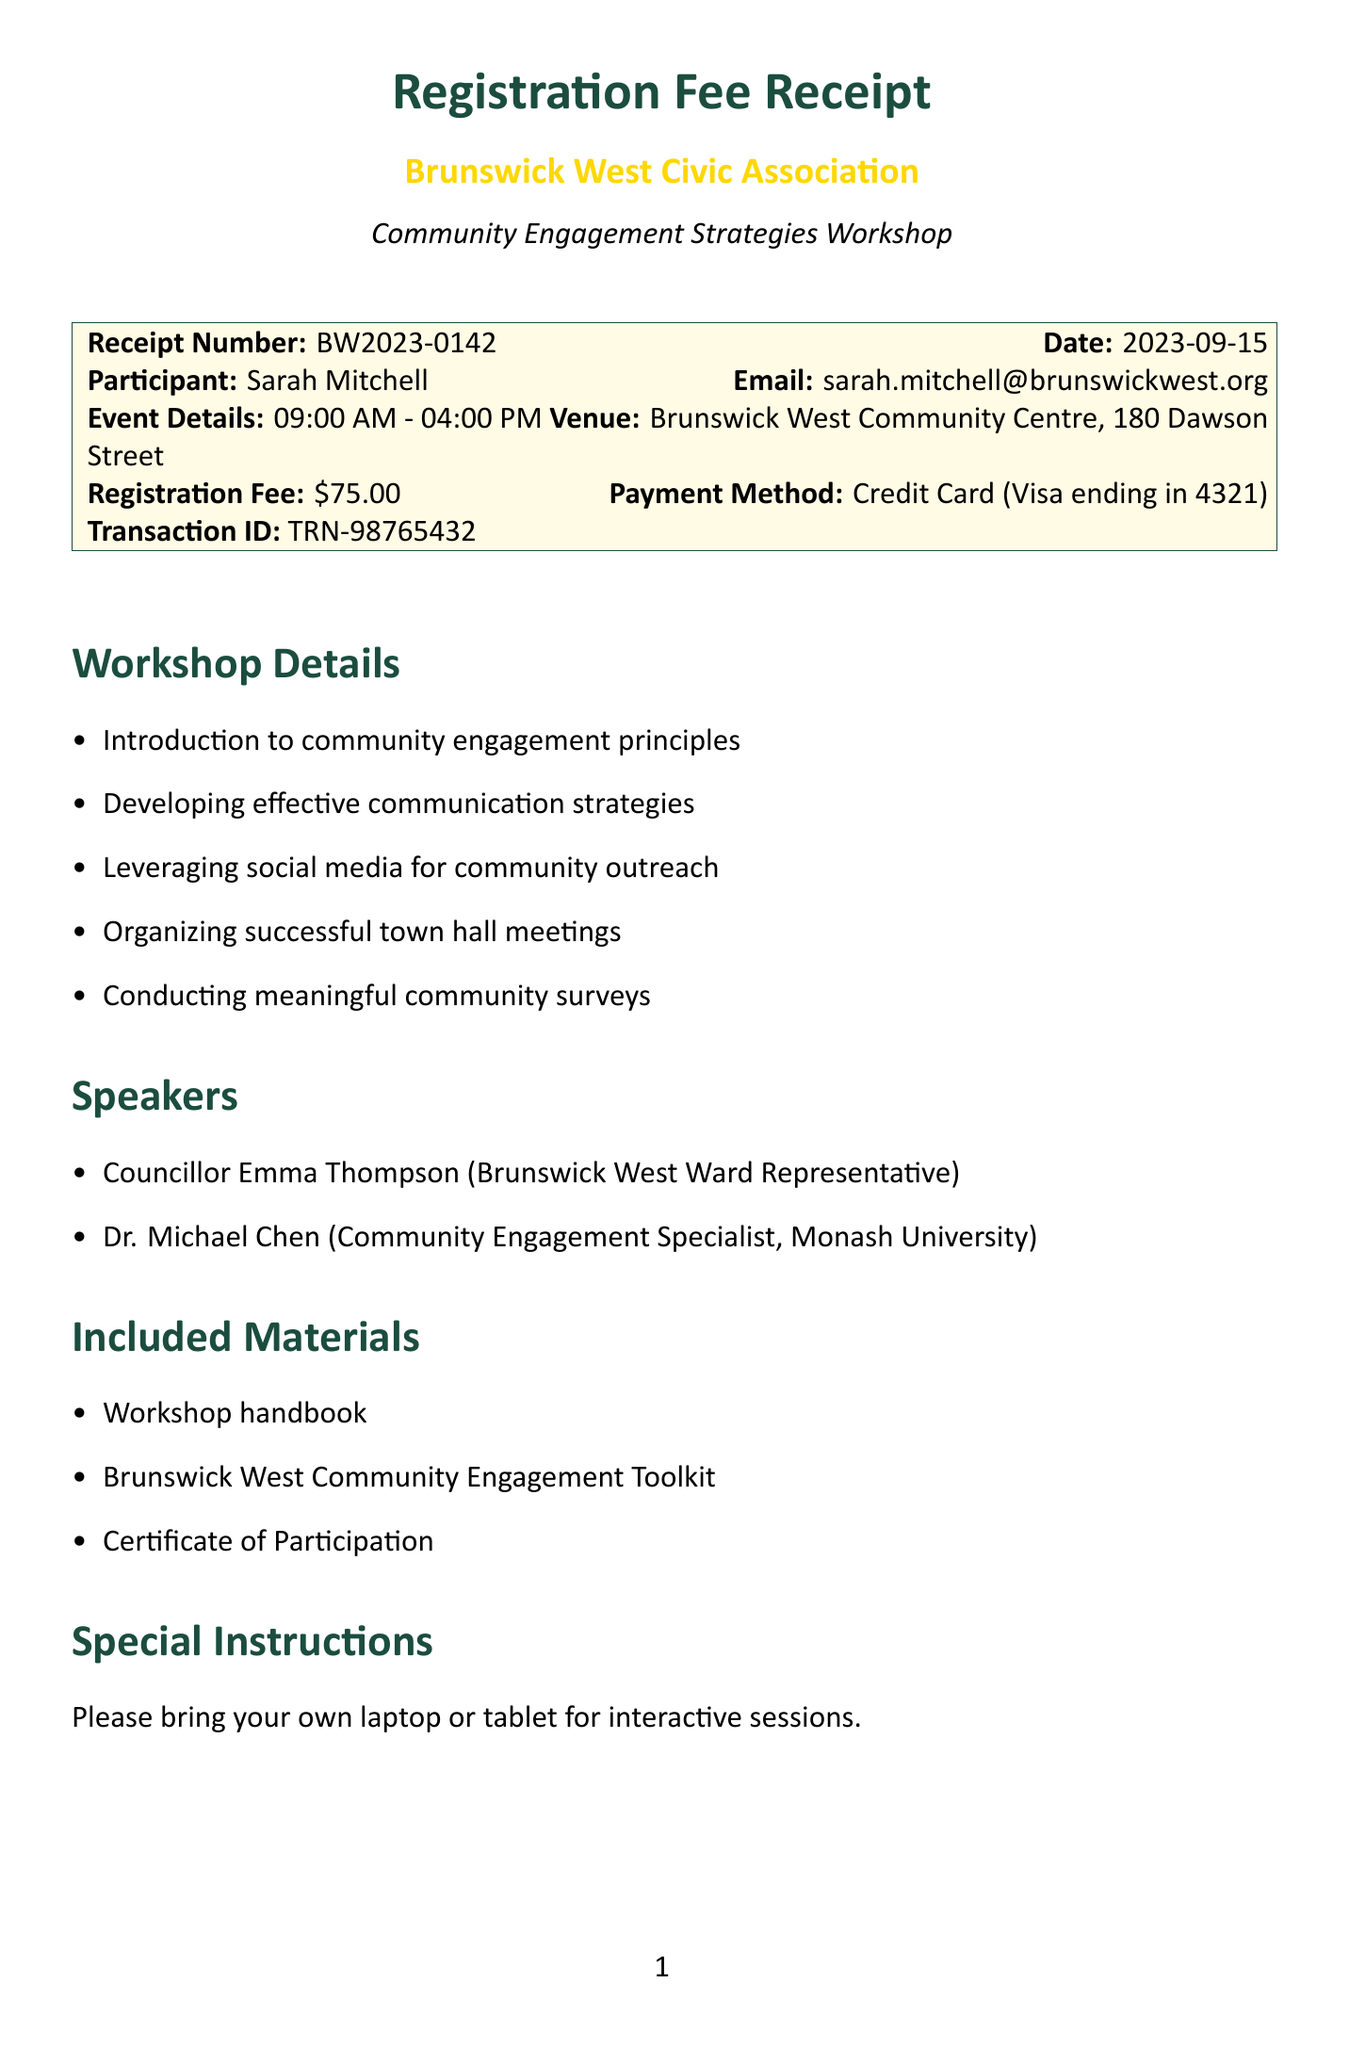What is the receipt number? The receipt number is a unique identifier for this transaction and can be found at the top of the document.
Answer: BW2023-0142 Who is the participant of the workshop? The participant's name is mentioned under the section for receipt details.
Answer: Sarah Mitchell What is the registration fee amount? The registration fee is specifically stated in the document under the receipt details section.
Answer: $75.00 What date is the workshop taking place? The date of the event is listed prominently in the header of the receipt.
Answer: 2023-09-15 What are the names of the speakers? The names of the speakers are listed in the relevant section of the document, summarizing their roles.
Answer: Councillor Emma Thompson, Dr. Michael Chen What is the cancellation policy for the workshop? The cancellation policy outlines the terms for refunds and can be found in its dedicated section.
Answer: Full refund available up to 7 days before the event. 50% refund within 7 days What kind of materials are included with the workshop? The document includes a section that details the materials participants will receive.
Answer: Workshop handbook, Brunswick West Community Engagement Toolkit, Certificate of Participation What special instruction is given to participants? Special instructions for attendees are specified to prepare for the interactive session.
Answer: Please bring your own laptop or tablet for interactive sessions What is the contact email for the event coordinator? The contact email is provided in the contact information section of the receipt.
Answer: events@brunswickwestcivic.org.au 